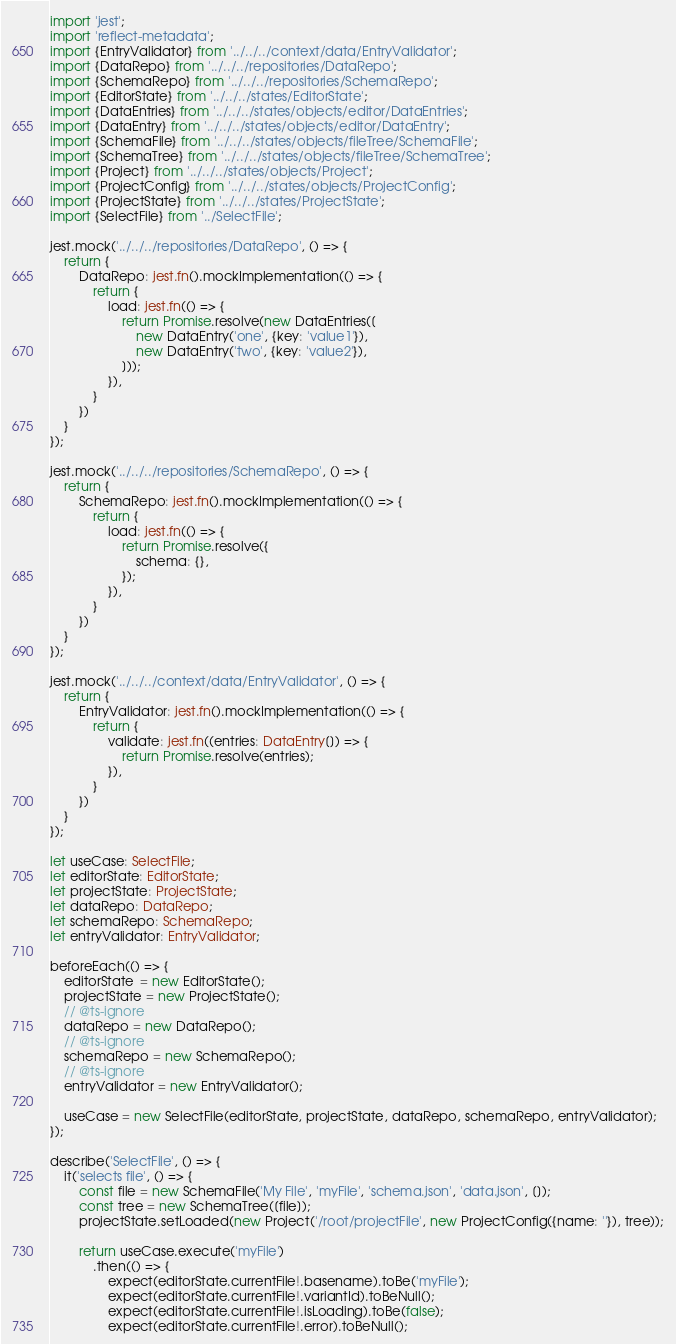<code> <loc_0><loc_0><loc_500><loc_500><_TypeScript_>import 'jest';
import 'reflect-metadata';
import {EntryValidator} from '../../../context/data/EntryValidator';
import {DataRepo} from '../../../repositories/DataRepo';
import {SchemaRepo} from '../../../repositories/SchemaRepo';
import {EditorState} from '../../../states/EditorState';
import {DataEntries} from '../../../states/objects/editor/DataEntries';
import {DataEntry} from '../../../states/objects/editor/DataEntry';
import {SchemaFile} from '../../../states/objects/fileTree/SchemaFile';
import {SchemaTree} from '../../../states/objects/fileTree/SchemaTree';
import {Project} from '../../../states/objects/Project';
import {ProjectConfig} from '../../../states/objects/ProjectConfig';
import {ProjectState} from '../../../states/ProjectState';
import {SelectFile} from '../SelectFile';

jest.mock('../../../repositories/DataRepo', () => {
    return {
        DataRepo: jest.fn().mockImplementation(() => {
            return {
                load: jest.fn(() => {
                    return Promise.resolve(new DataEntries([
                        new DataEntry('one', {key: 'value1'}),
                        new DataEntry('two', {key: 'value2'}),
                    ]));
                }),
            }
        })
    }
});

jest.mock('../../../repositories/SchemaRepo', () => {
    return {
        SchemaRepo: jest.fn().mockImplementation(() => {
            return {
                load: jest.fn(() => {
                    return Promise.resolve({
                        schema: {},
                    });
                }),
            }
        })
    }
});

jest.mock('../../../context/data/EntryValidator', () => {
    return {
        EntryValidator: jest.fn().mockImplementation(() => {
            return {
                validate: jest.fn((entries: DataEntry[]) => {
                    return Promise.resolve(entries);
                }),
            }
        })
    }
});

let useCase: SelectFile;
let editorState: EditorState;
let projectState: ProjectState;
let dataRepo: DataRepo;
let schemaRepo: SchemaRepo;
let entryValidator: EntryValidator;

beforeEach(() => {
    editorState  = new EditorState();
    projectState = new ProjectState();
    // @ts-ignore
    dataRepo = new DataRepo();
    // @ts-ignore
    schemaRepo = new SchemaRepo();
    // @ts-ignore
    entryValidator = new EntryValidator();

    useCase = new SelectFile(editorState, projectState, dataRepo, schemaRepo, entryValidator);
});

describe('SelectFile', () => {
    it('selects file', () => {
        const file = new SchemaFile('My File', 'myFile', 'schema.json', 'data.json', []);
        const tree = new SchemaTree([file]);
        projectState.setLoaded(new Project('/root/projectFile', new ProjectConfig({name: ''}), tree));

        return useCase.execute('myFile')
            .then(() => {
                expect(editorState.currentFile!.basename).toBe('myFile');
                expect(editorState.currentFile!.variantId).toBeNull();
                expect(editorState.currentFile!.isLoading).toBe(false);
                expect(editorState.currentFile!.error).toBeNull();</code> 